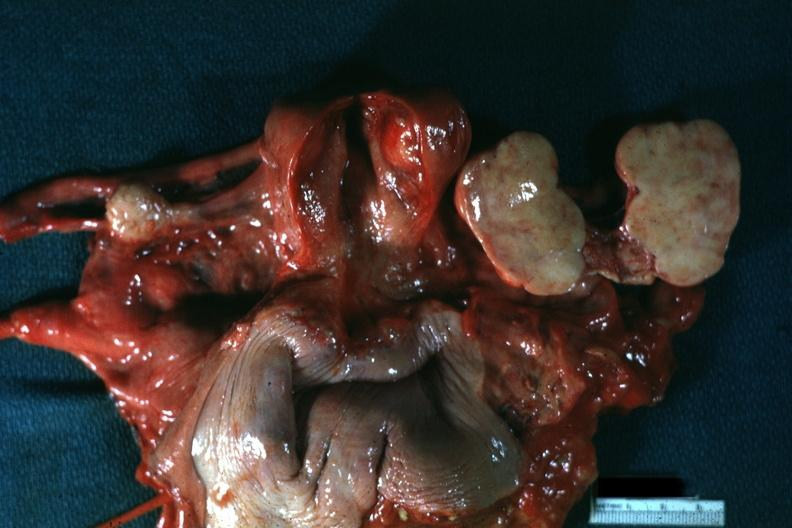what is present?
Answer the question using a single word or phrase. Ovary 